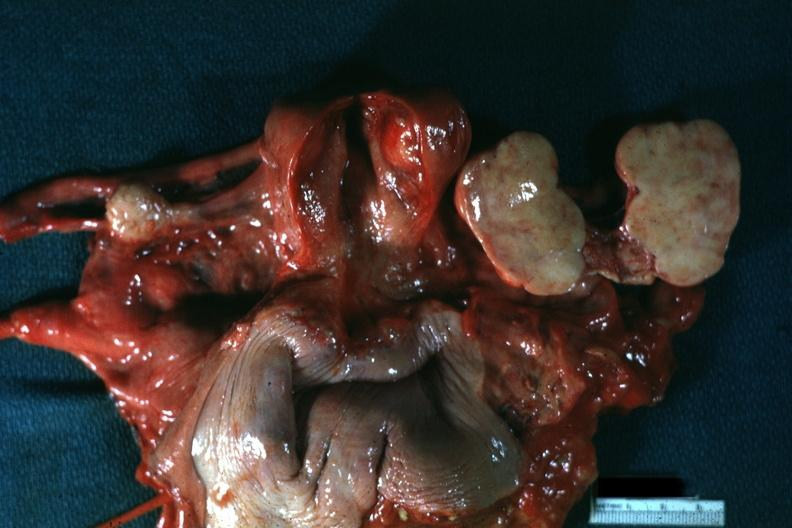what is present?
Answer the question using a single word or phrase. Ovary 